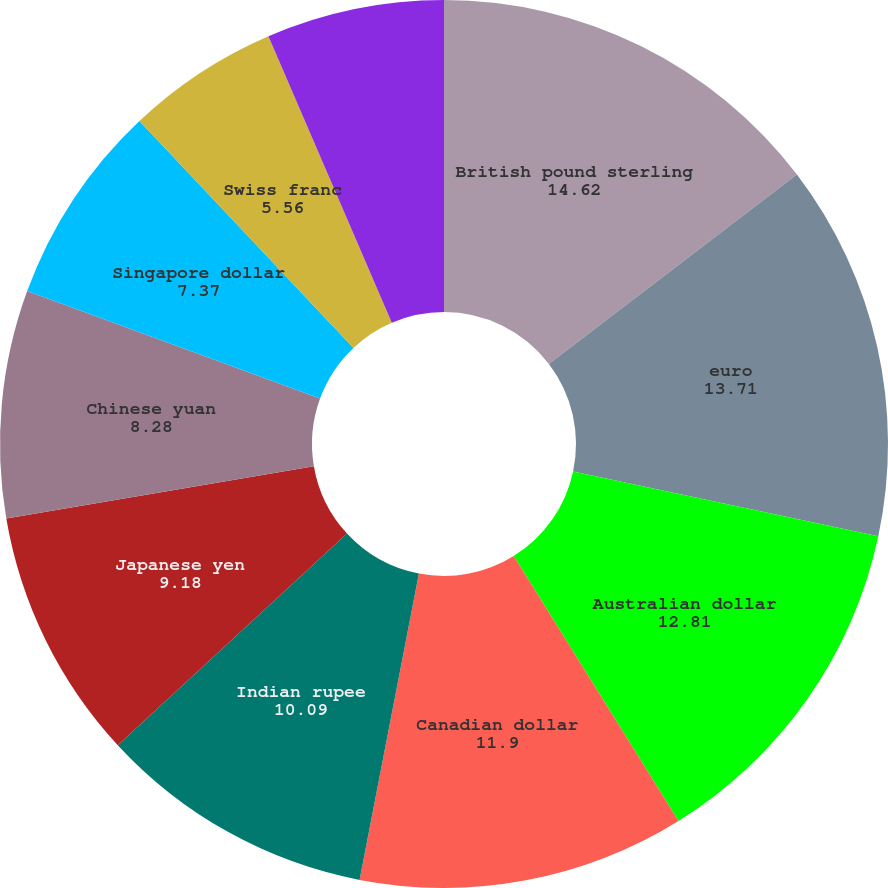Convert chart to OTSL. <chart><loc_0><loc_0><loc_500><loc_500><pie_chart><fcel>British pound sterling<fcel>euro<fcel>Australian dollar<fcel>Canadian dollar<fcel>Indian rupee<fcel>Japanese yen<fcel>Chinese yuan<fcel>Singapore dollar<fcel>Swiss franc<fcel>Hong Kong dollar<nl><fcel>14.62%<fcel>13.71%<fcel>12.81%<fcel>11.9%<fcel>10.09%<fcel>9.18%<fcel>8.28%<fcel>7.37%<fcel>5.56%<fcel>6.47%<nl></chart> 